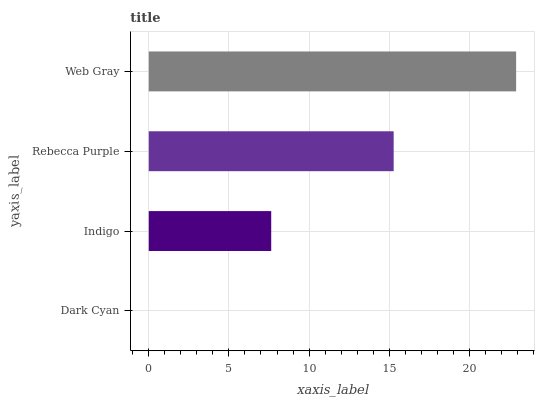Is Dark Cyan the minimum?
Answer yes or no. Yes. Is Web Gray the maximum?
Answer yes or no. Yes. Is Indigo the minimum?
Answer yes or no. No. Is Indigo the maximum?
Answer yes or no. No. Is Indigo greater than Dark Cyan?
Answer yes or no. Yes. Is Dark Cyan less than Indigo?
Answer yes or no. Yes. Is Dark Cyan greater than Indigo?
Answer yes or no. No. Is Indigo less than Dark Cyan?
Answer yes or no. No. Is Rebecca Purple the high median?
Answer yes or no. Yes. Is Indigo the low median?
Answer yes or no. Yes. Is Indigo the high median?
Answer yes or no. No. Is Dark Cyan the low median?
Answer yes or no. No. 